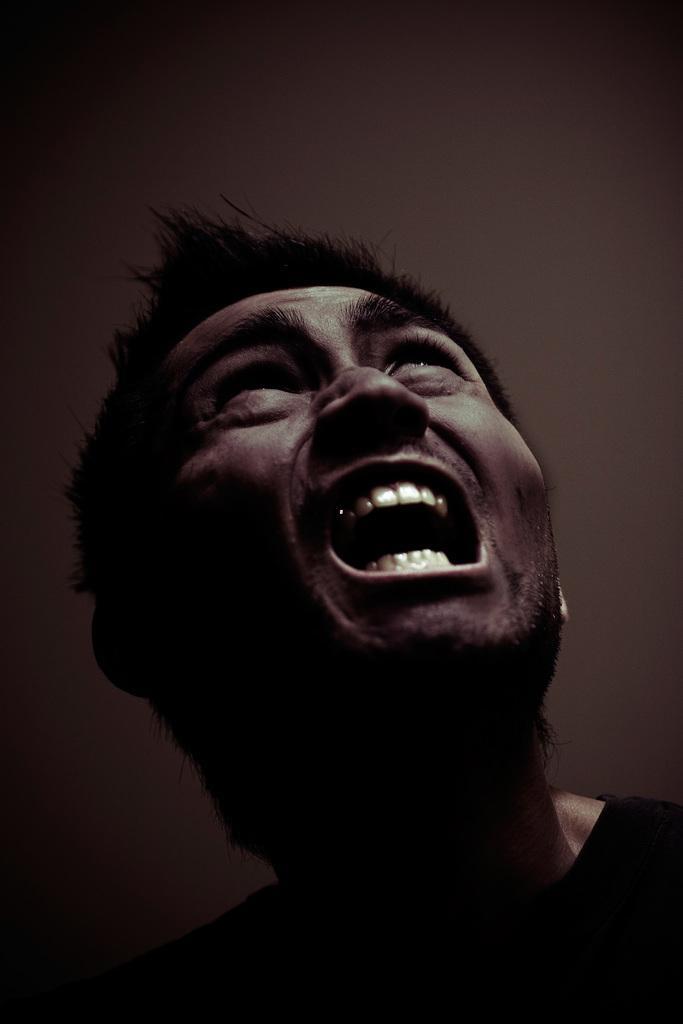How would you summarize this image in a sentence or two? In the image we can see there is a person and the image is in black and white colour. 